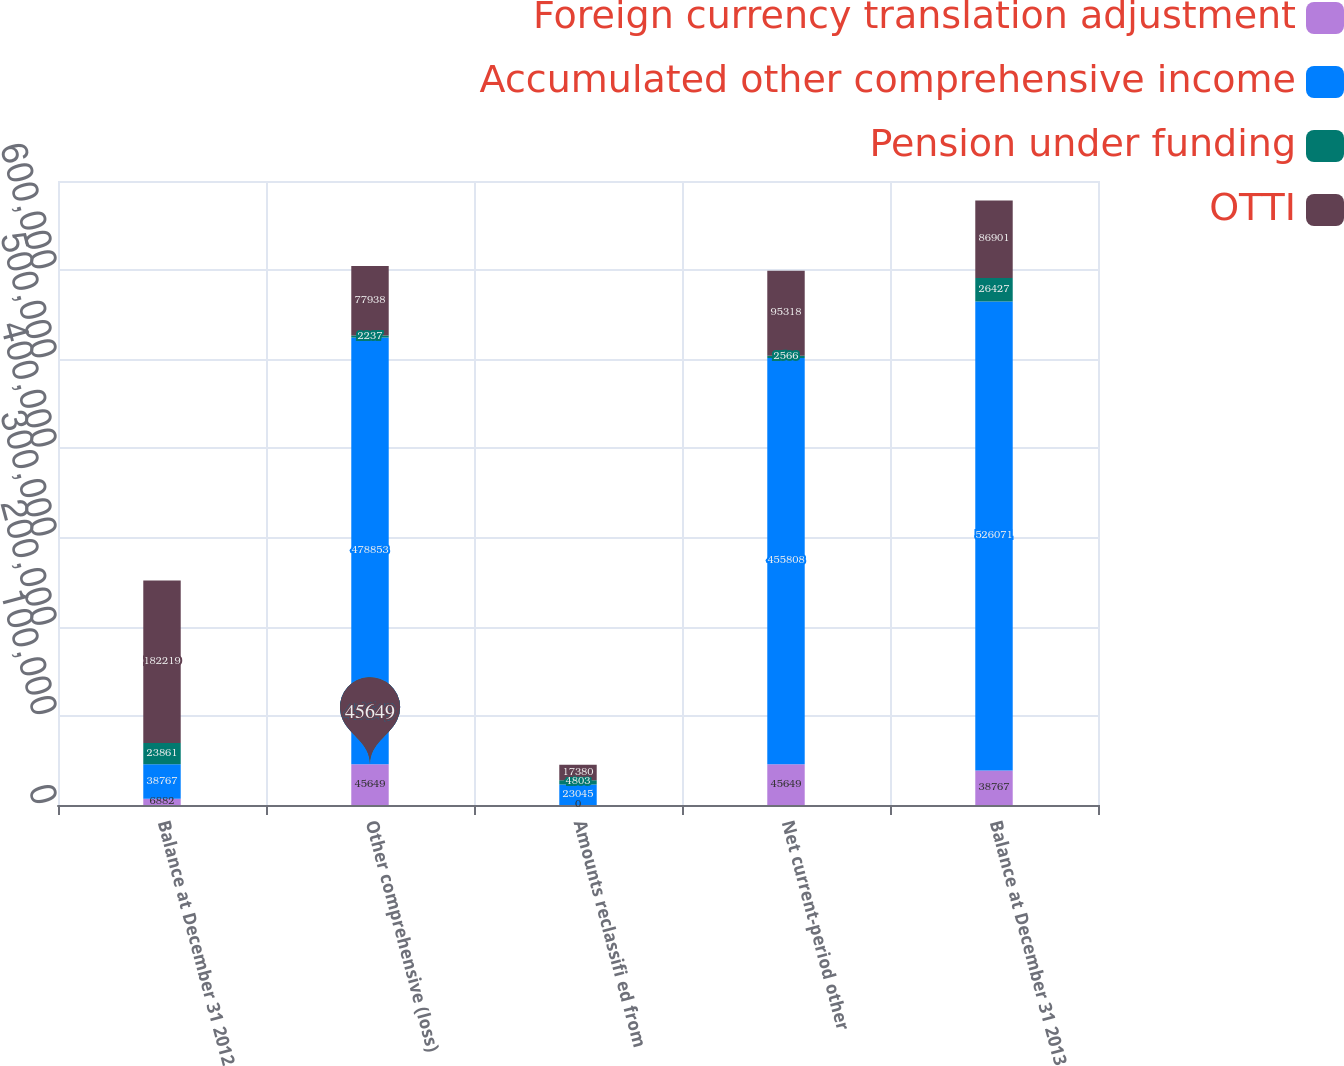<chart> <loc_0><loc_0><loc_500><loc_500><stacked_bar_chart><ecel><fcel>Balance at December 31 2012<fcel>Other comprehensive (loss)<fcel>Amounts reclassifi ed from<fcel>Net current-period other<fcel>Balance at December 31 2013<nl><fcel>Foreign currency translation adjustment<fcel>6882<fcel>45649<fcel>0<fcel>45649<fcel>38767<nl><fcel>Accumulated other comprehensive income<fcel>38767<fcel>478853<fcel>23045<fcel>455808<fcel>526071<nl><fcel>Pension under funding<fcel>23861<fcel>2237<fcel>4803<fcel>2566<fcel>26427<nl><fcel>OTTI<fcel>182219<fcel>77938<fcel>17380<fcel>95318<fcel>86901<nl></chart> 